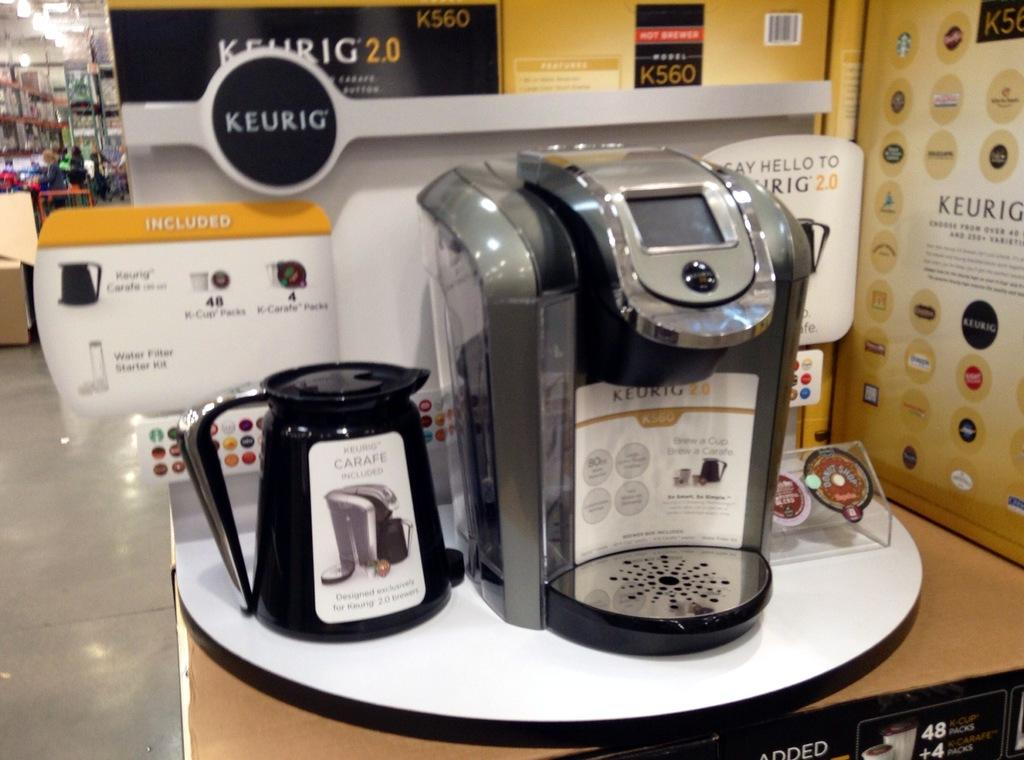Provide a one-sentence caption for the provided image. The K cup machine sitting on the table is made by Keurig. 